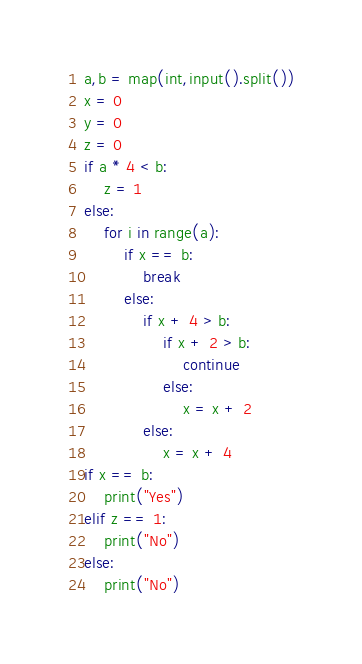<code> <loc_0><loc_0><loc_500><loc_500><_Python_>a,b = map(int,input().split())
x = 0
y = 0
z = 0
if a * 4 < b:
    z = 1
else:
    for i in range(a):
        if x == b:
            break
        else:
            if x + 4 > b:
                if x + 2 > b:
                    continue
                else:
                    x = x + 2
            else:
                x = x + 4
if x == b:
    print("Yes")
elif z == 1:
    print("No")
else:
    print("No")</code> 